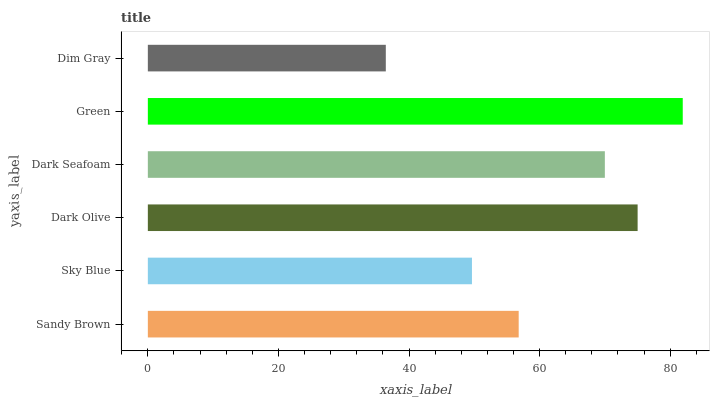Is Dim Gray the minimum?
Answer yes or no. Yes. Is Green the maximum?
Answer yes or no. Yes. Is Sky Blue the minimum?
Answer yes or no. No. Is Sky Blue the maximum?
Answer yes or no. No. Is Sandy Brown greater than Sky Blue?
Answer yes or no. Yes. Is Sky Blue less than Sandy Brown?
Answer yes or no. Yes. Is Sky Blue greater than Sandy Brown?
Answer yes or no. No. Is Sandy Brown less than Sky Blue?
Answer yes or no. No. Is Dark Seafoam the high median?
Answer yes or no. Yes. Is Sandy Brown the low median?
Answer yes or no. Yes. Is Sky Blue the high median?
Answer yes or no. No. Is Dark Olive the low median?
Answer yes or no. No. 